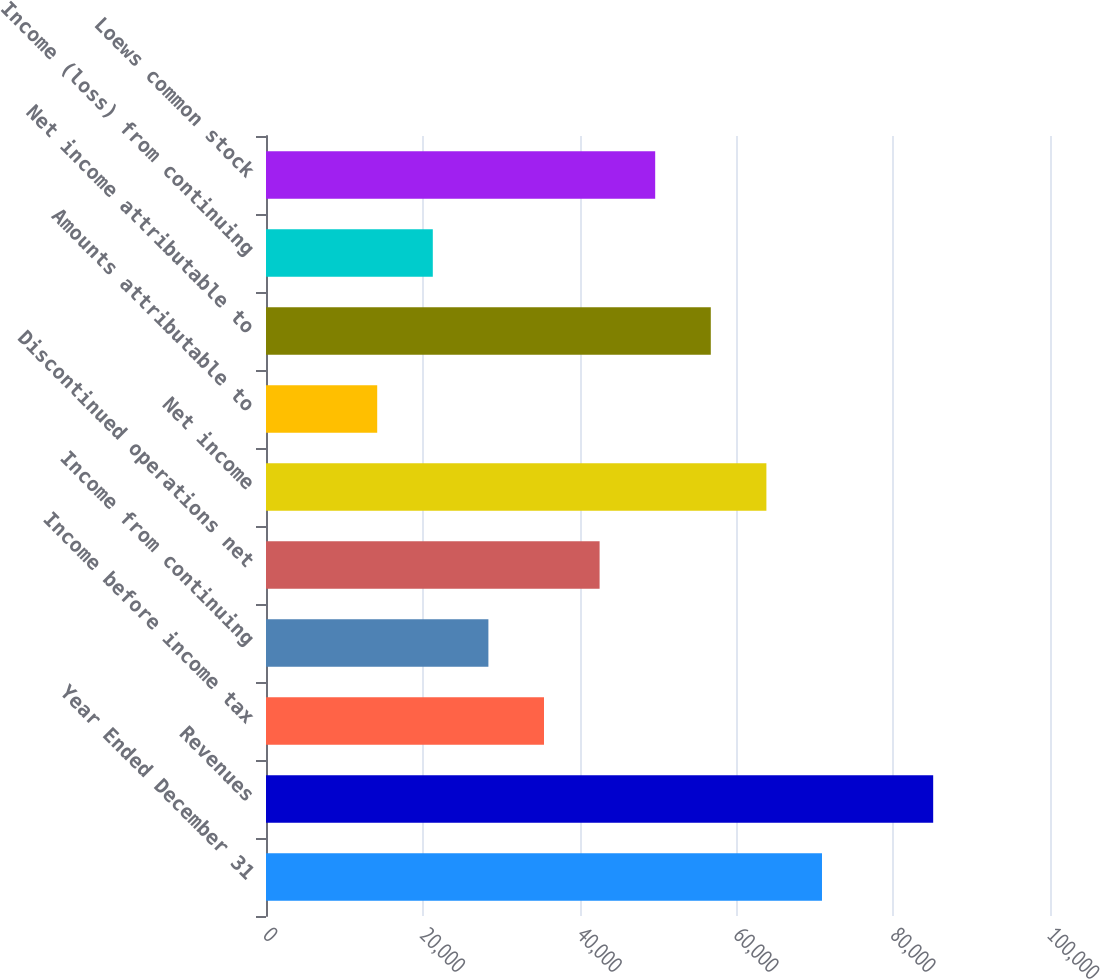Convert chart to OTSL. <chart><loc_0><loc_0><loc_500><loc_500><bar_chart><fcel>Year Ended December 31<fcel>Revenues<fcel>Income before income tax<fcel>Income from continuing<fcel>Discontinued operations net<fcel>Net income<fcel>Amounts attributable to<fcel>Net income attributable to<fcel>Income (loss) from continuing<fcel>Loews common stock<nl><fcel>70917<fcel>85100.3<fcel>35458.9<fcel>28367.3<fcel>42550.6<fcel>63825.4<fcel>14184.1<fcel>56733.8<fcel>21275.7<fcel>49642.2<nl></chart> 